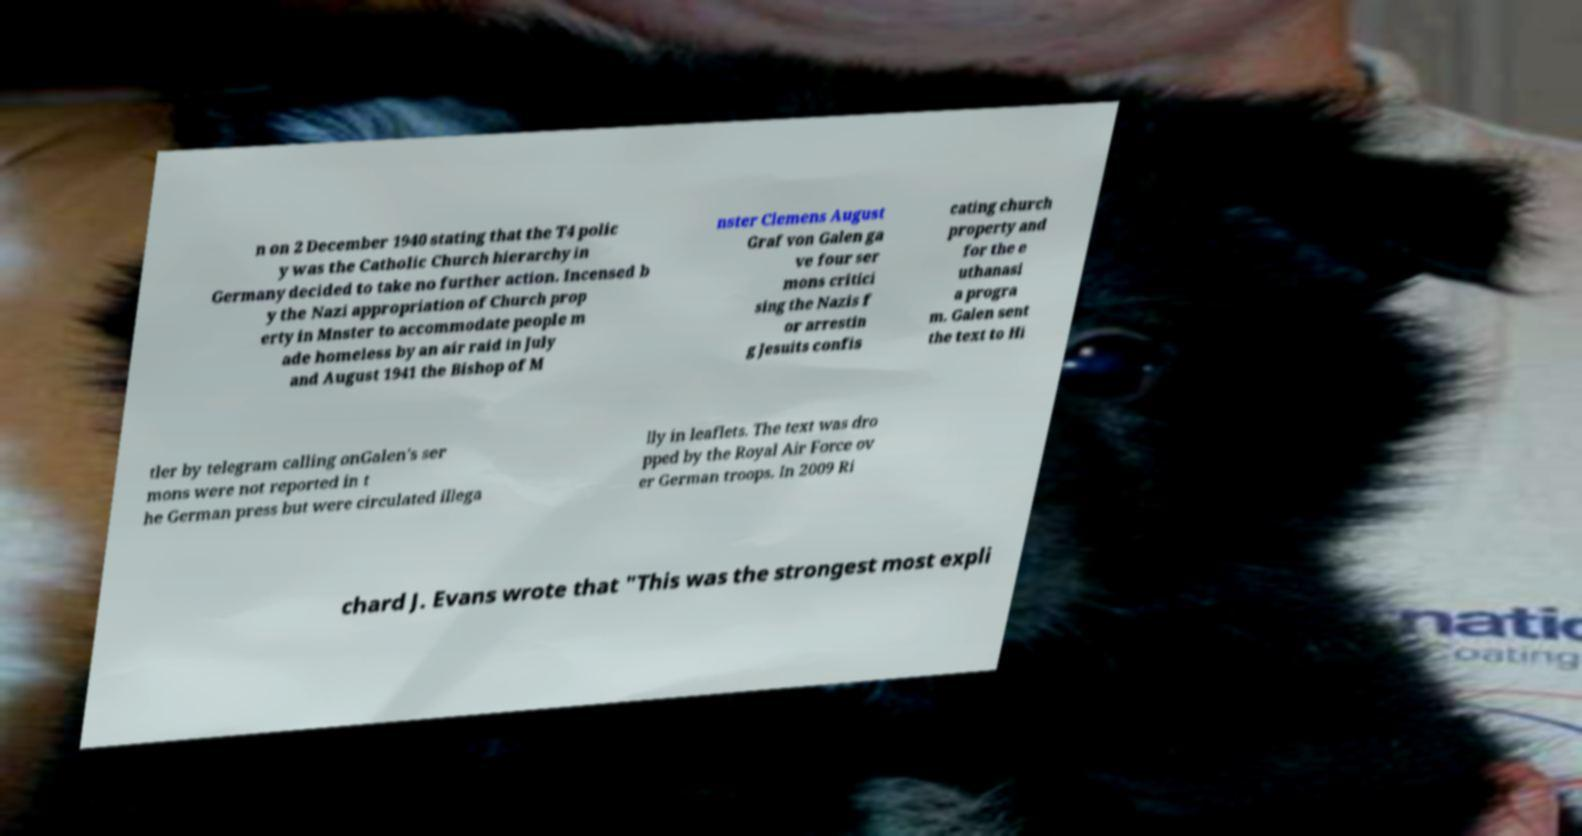Please identify and transcribe the text found in this image. n on 2 December 1940 stating that the T4 polic y was the Catholic Church hierarchy in Germany decided to take no further action. Incensed b y the Nazi appropriation of Church prop erty in Mnster to accommodate people m ade homeless by an air raid in July and August 1941 the Bishop of M nster Clemens August Graf von Galen ga ve four ser mons critici sing the Nazis f or arrestin g Jesuits confis cating church property and for the e uthanasi a progra m. Galen sent the text to Hi tler by telegram calling onGalen's ser mons were not reported in t he German press but were circulated illega lly in leaflets. The text was dro pped by the Royal Air Force ov er German troops. In 2009 Ri chard J. Evans wrote that "This was the strongest most expli 